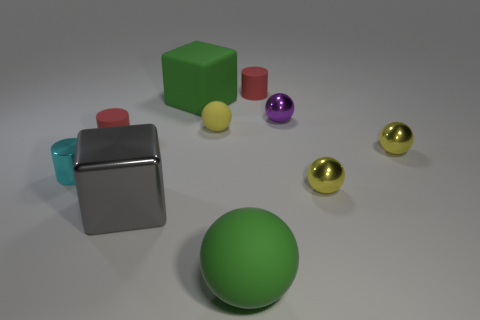What color is the big thing that is the same material as the cyan cylinder?
Give a very brief answer. Gray. There is a yellow matte object; does it have the same size as the red matte thing behind the small purple metallic sphere?
Your answer should be compact. Yes. There is a large shiny thing; what shape is it?
Give a very brief answer. Cube. What number of other shiny cubes are the same color as the large metal block?
Your answer should be very brief. 0. What is the color of the other thing that is the same shape as the large gray shiny thing?
Provide a short and direct response. Green. How many large green rubber cubes are right of the big object that is on the right side of the big green block?
Provide a short and direct response. 0. How many cubes are small red things or large gray metal things?
Provide a succinct answer. 1. Are any brown matte cylinders visible?
Give a very brief answer. No. What size is the other matte object that is the same shape as the big gray object?
Offer a very short reply. Large. There is a yellow object behind the tiny red cylinder that is in front of the tiny purple shiny ball; what is its shape?
Offer a very short reply. Sphere. 